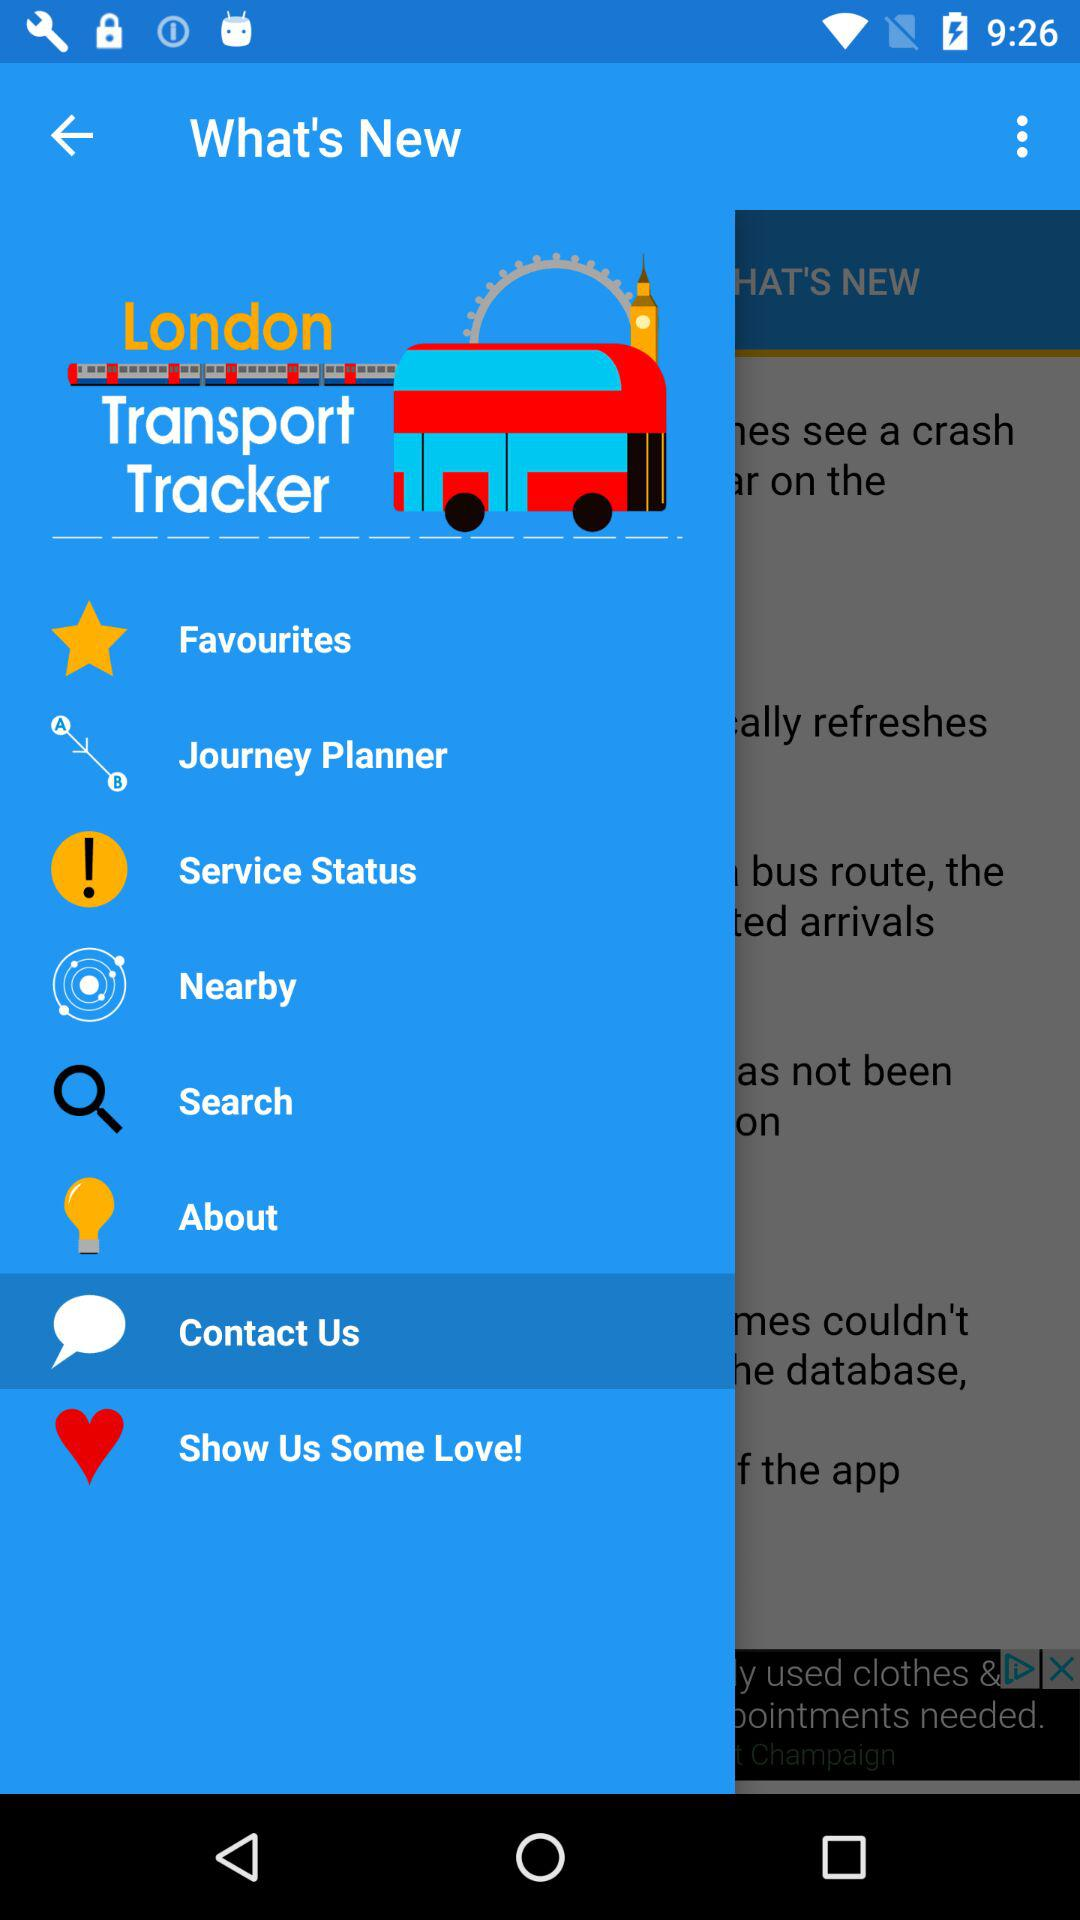What is the app name? The app name is "London Transport Tracker". 